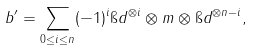Convert formula to latex. <formula><loc_0><loc_0><loc_500><loc_500>b ^ { \prime } = \sum _ { 0 \leq i \leq n } ( - 1 ) ^ { i } \i d ^ { \otimes i } \otimes m \otimes \i d ^ { \otimes n - i } ,</formula> 